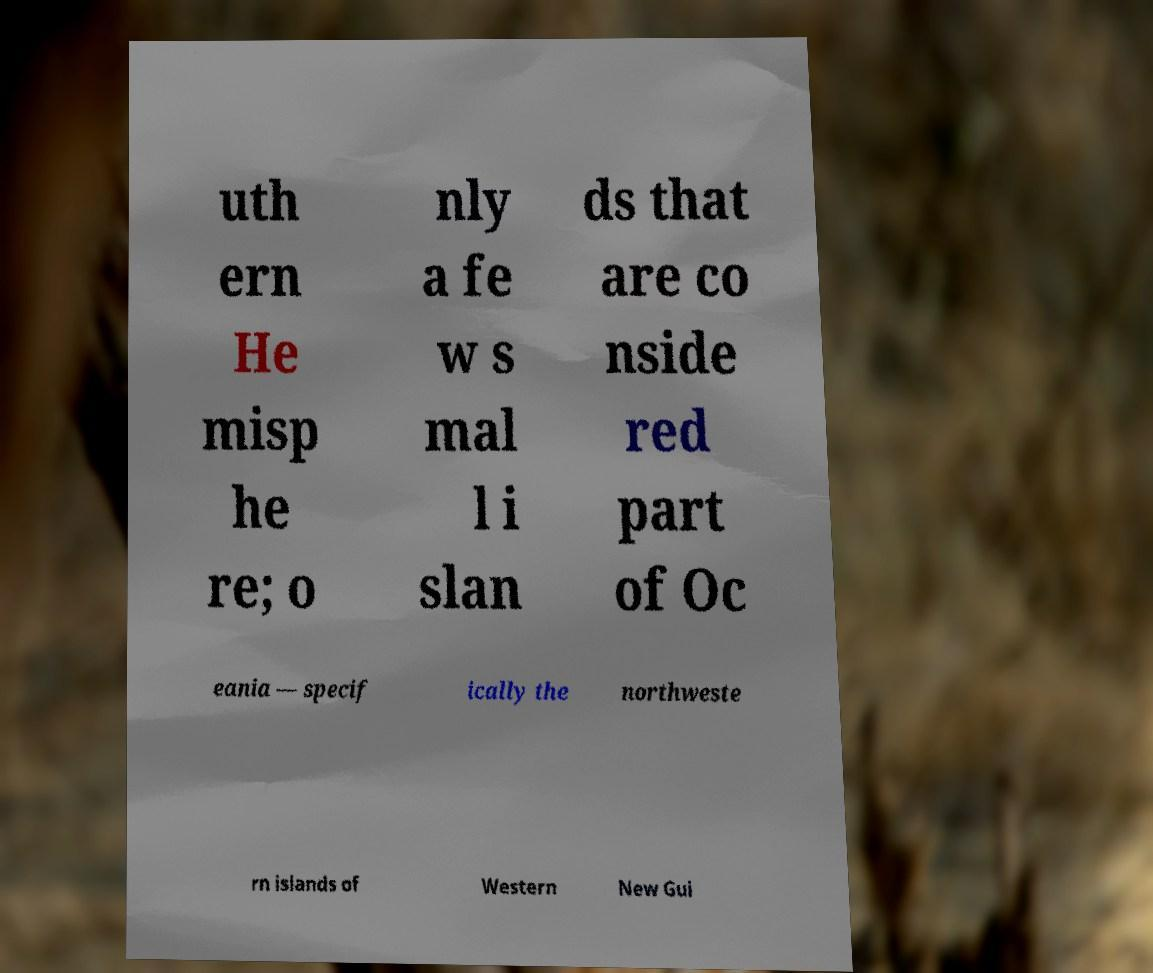Can you accurately transcribe the text from the provided image for me? uth ern He misp he re; o nly a fe w s mal l i slan ds that are co nside red part of Oc eania — specif ically the northweste rn islands of Western New Gui 